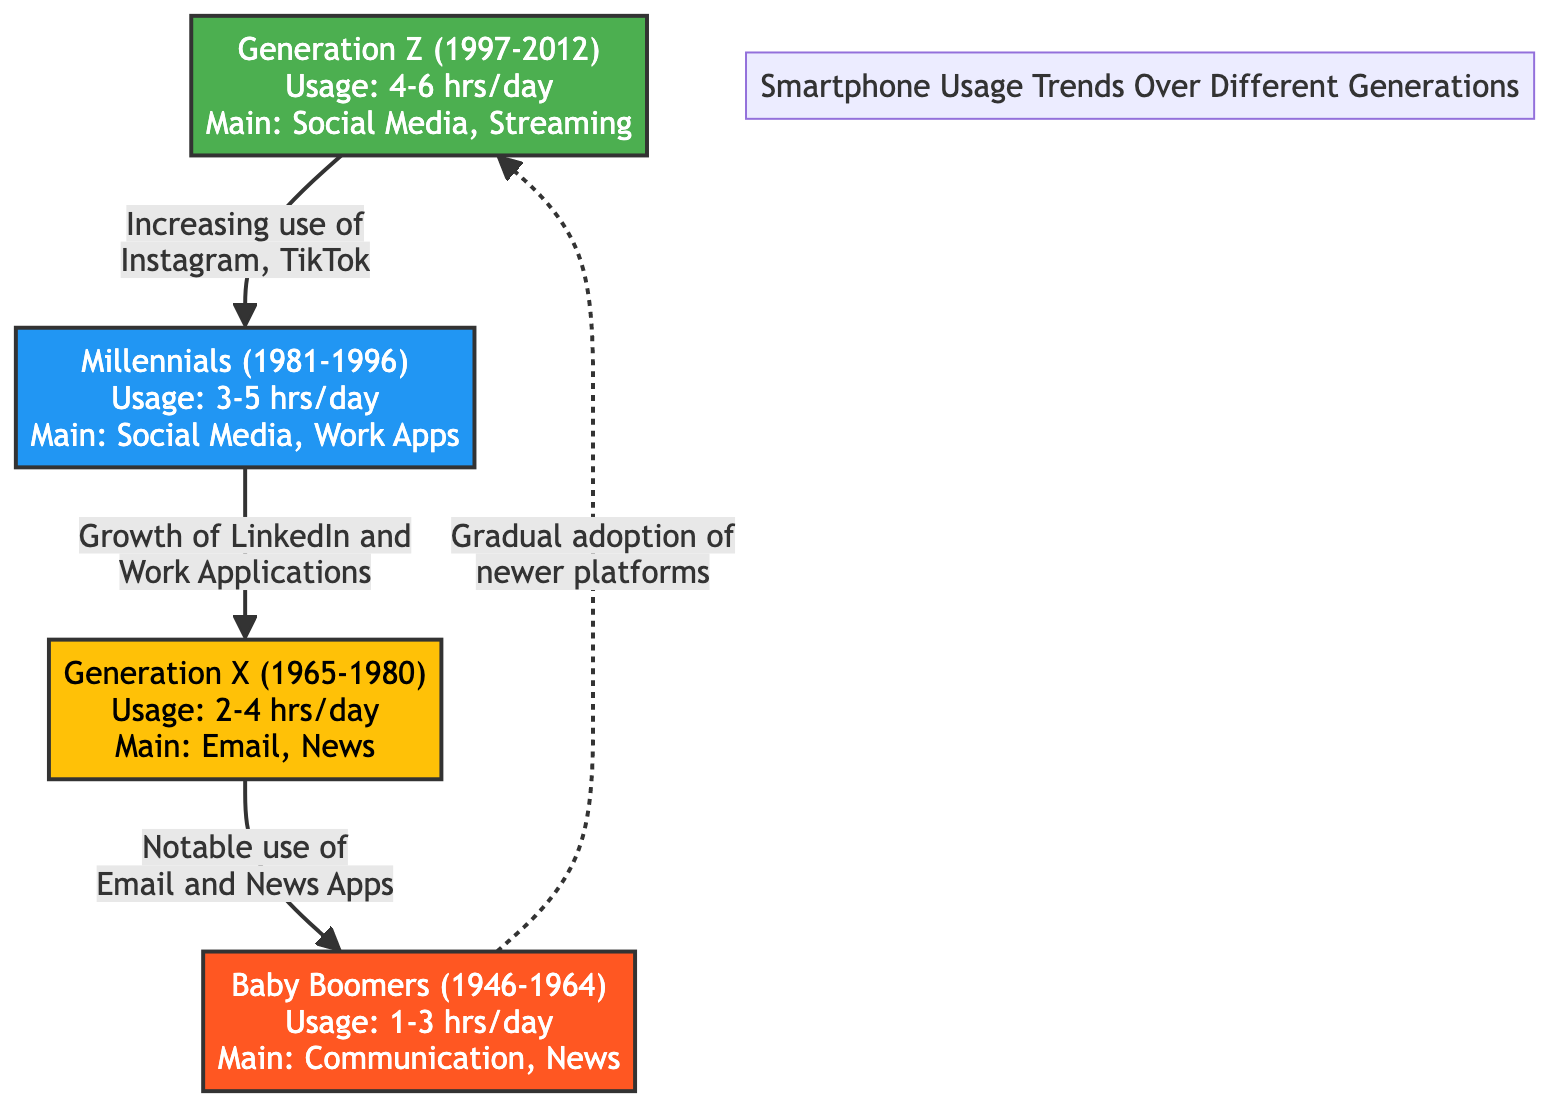What is the average daily smartphone usage for Generation Z? The diagram states that Generation Z's usage is 4-6 hours per day. To find the average, I take the midpoint of the range: (4 + 6) / 2 = 5 hours.
Answer: 5 hours What is the primary activity for Baby Boomers on smartphones? The diagram indicates that Baby Boomers' main usage is for Communication and News. Therefore, the primary activity is simply stated as "Communication."
Answer: Communication How many distinct generations are represented in the diagram? The diagram explicitly lists four generations: Generation Z, Millennials, Generation X, and Baby Boomers. Therefore, I count them to find a total of four.
Answer: 4 What is the trend for Generation X’s smartphone usage regarding social media? Generation X is noted for the notable use of Email and News Apps. There is no direct mention of social media usage, indicating a lesser trend in that area. Thus, the answer is "Low."
Answer: Low Which generation shows an increasing trend in the use of Instagram and TikTok? The diagram clearly states that the increasing use of Instagram and TikTok is associated with Generation Z. Thus, it can be directly derived from the node's information.
Answer: Generation Z How are Millennials expected to connect with Generation X based on the diagram? The diagram shows an arrow from Millennials to Generation X indicating "Growth of LinkedIn and Work Applications." This implies that Millennials influence Generation X through their increased usage of such platforms.
Answer: Growth of LinkedIn What activity is least associated with communication for Baby Boomers? The diagram illustrates that communication and news are the main activities for Baby Boomers. Since social media is linked to Generation Z and not to Baby Boomers, we can conclude that social media is least associated.
Answer: Social Media What is the primary difference in smartphone usage duration between Generation X and Baby Boomers? From the diagram, Generation X uses smartphones for 2-4 hours daily, and Baby Boomers use them for 1-3 hours daily. The difference in their maximum usage times is 4 - 3 = 1 hour, while the minimum usage difference is 2 - 1 = 1 hour. Thus, the primary difference is calculated considering both max and min usage ranges.
Answer: 1 hour What is the main usage focus for Millennials according to the diagram? The diagram indicates that Millennials primarily use smartphones for Social Media and Work Apps. Hence, stating the main usage focus would be clearly highlighted in the node labeled "Millennials."
Answer: Social Media, Work Apps 